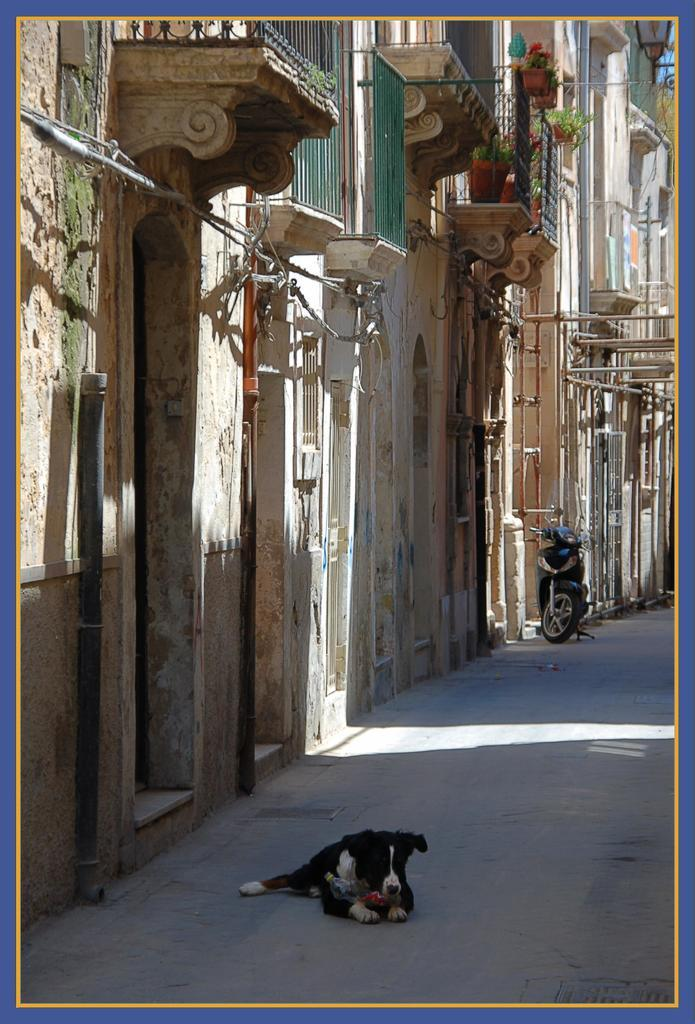What animal is sitting on the road in the image? There is a dog sitting on the road in the image. What type of vehicle is present in the image? There is a motorcycle in the image. What structures can be seen in the image? There are buildings in the image. What type of illumination is present in the image? There is a light in the image. What type of vegetation is present in the image? There are plants in the image. What type of skirt is the sheep wearing in the image? There is no sheep or skirt present in the image. How many boys are visible in the image? There are no boys present in the image. 